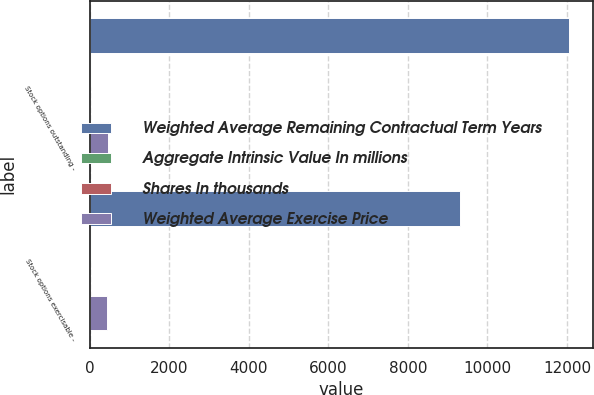Convert chart. <chart><loc_0><loc_0><loc_500><loc_500><stacked_bar_chart><ecel><fcel>Stock options outstanding -<fcel>Stock options exercisable -<nl><fcel>Weighted Average Remaining Contractual Term Years<fcel>12052<fcel>9319<nl><fcel>Aggregate Intrinsic Value In millions<fcel>33.96<fcel>26.2<nl><fcel>Shares In thousands<fcel>5.2<fcel>4.3<nl><fcel>Weighted Average Exercise Price<fcel>477<fcel>441<nl></chart> 